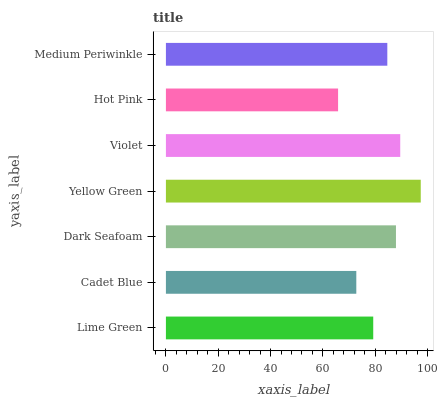Is Hot Pink the minimum?
Answer yes or no. Yes. Is Yellow Green the maximum?
Answer yes or no. Yes. Is Cadet Blue the minimum?
Answer yes or no. No. Is Cadet Blue the maximum?
Answer yes or no. No. Is Lime Green greater than Cadet Blue?
Answer yes or no. Yes. Is Cadet Blue less than Lime Green?
Answer yes or no. Yes. Is Cadet Blue greater than Lime Green?
Answer yes or no. No. Is Lime Green less than Cadet Blue?
Answer yes or no. No. Is Medium Periwinkle the high median?
Answer yes or no. Yes. Is Medium Periwinkle the low median?
Answer yes or no. Yes. Is Lime Green the high median?
Answer yes or no. No. Is Lime Green the low median?
Answer yes or no. No. 